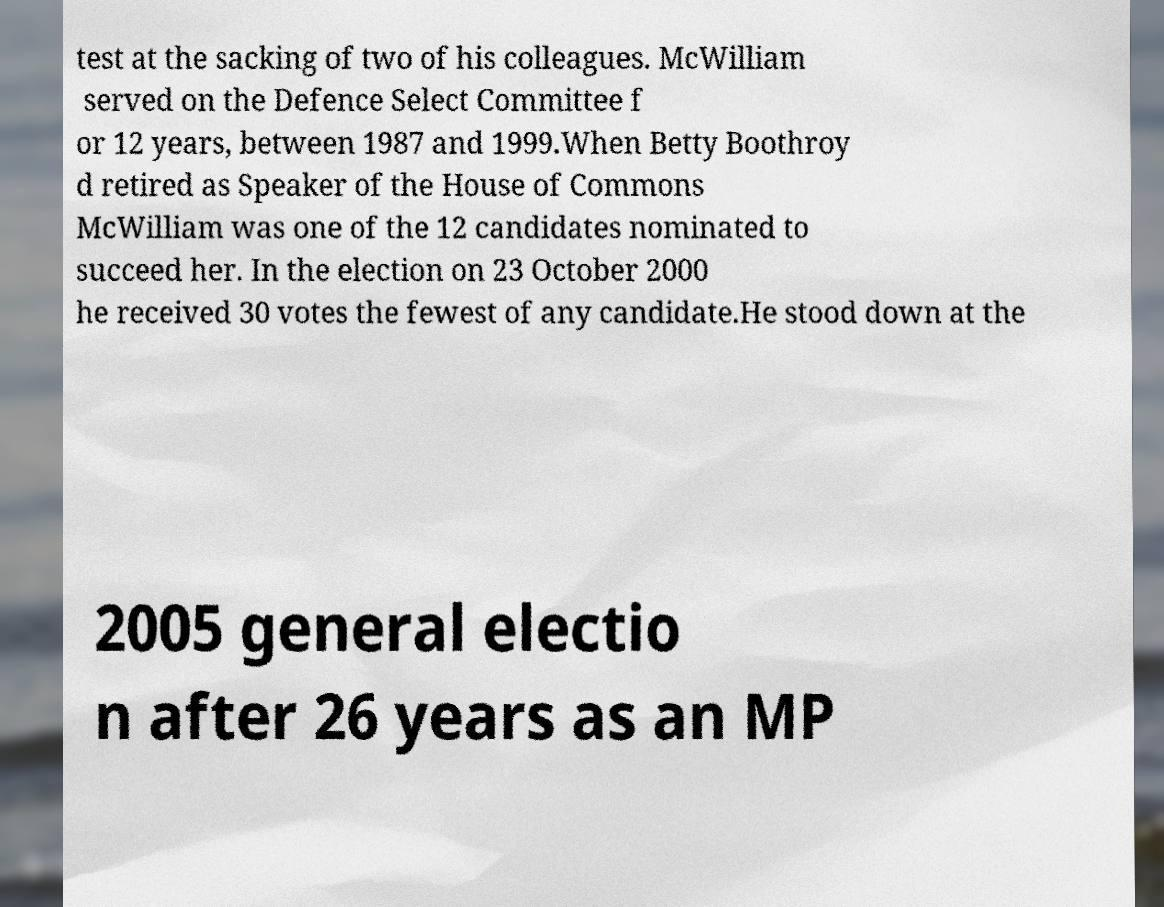Can you read and provide the text displayed in the image?This photo seems to have some interesting text. Can you extract and type it out for me? test at the sacking of two of his colleagues. McWilliam served on the Defence Select Committee f or 12 years, between 1987 and 1999.When Betty Boothroy d retired as Speaker of the House of Commons McWilliam was one of the 12 candidates nominated to succeed her. In the election on 23 October 2000 he received 30 votes the fewest of any candidate.He stood down at the 2005 general electio n after 26 years as an MP 